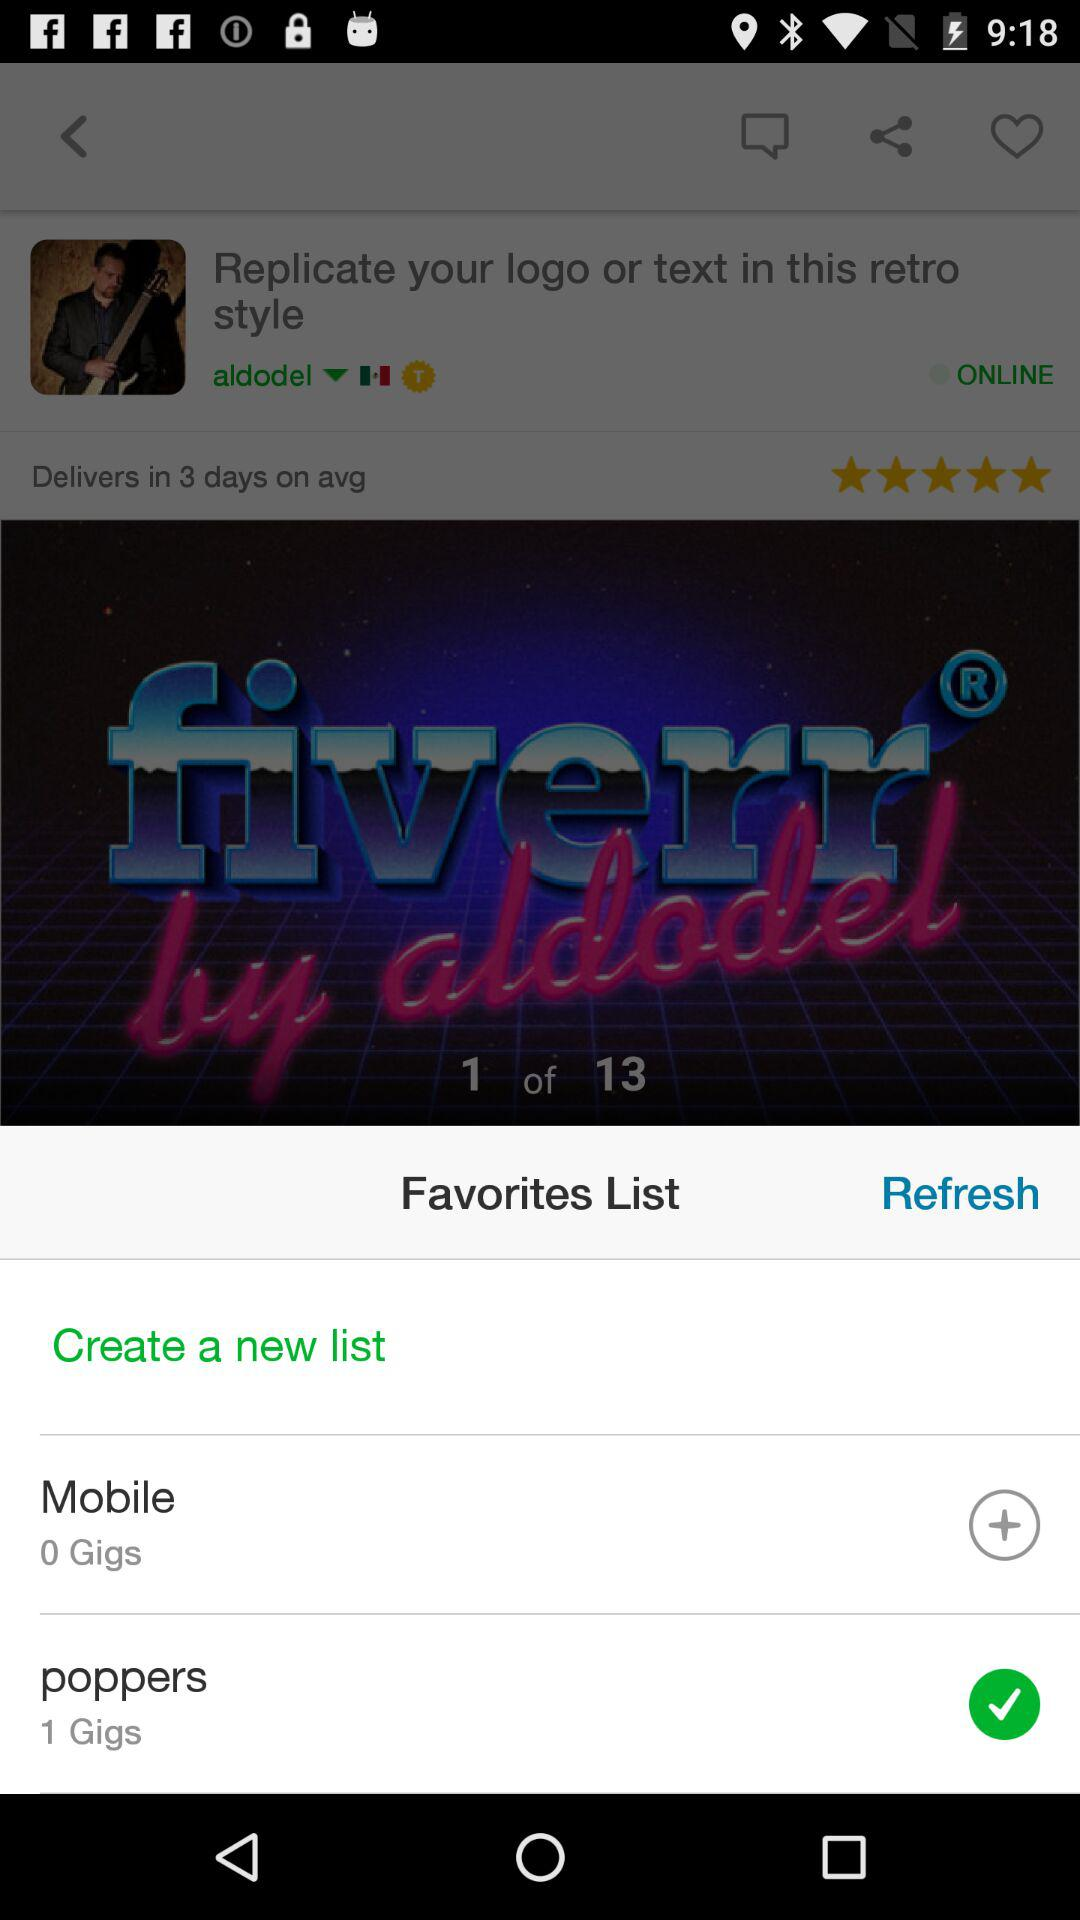How many total images? The total images are 13. 